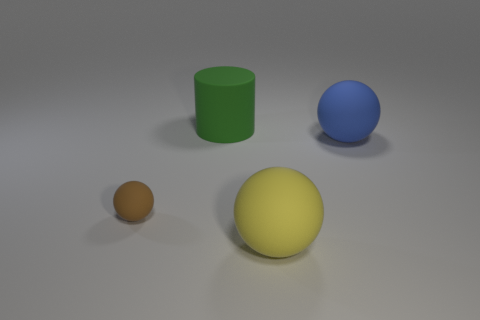Subtract all brown rubber spheres. How many spheres are left? 2 Subtract all yellow spheres. How many spheres are left? 2 Subtract all cylinders. How many objects are left? 3 Subtract 2 balls. How many balls are left? 1 Add 3 large blue rubber things. How many large blue rubber things are left? 4 Add 2 green cylinders. How many green cylinders exist? 3 Add 3 large blue matte blocks. How many objects exist? 7 Subtract 1 green cylinders. How many objects are left? 3 Subtract all purple cylinders. Subtract all brown blocks. How many cylinders are left? 1 Subtract all green cylinders. How many yellow spheres are left? 1 